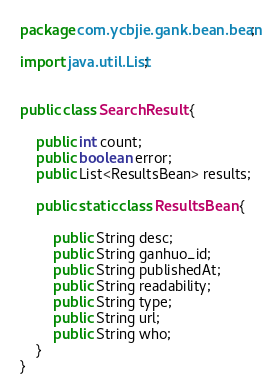<code> <loc_0><loc_0><loc_500><loc_500><_Java_>package com.ycbjie.gank.bean.bean;

import java.util.List;


public class SearchResult {

    public int count;
    public boolean error;
    public List<ResultsBean> results;

    public static class ResultsBean {

        public String desc;
        public String ganhuo_id;
        public String publishedAt;
        public String readability;
        public String type;
        public String url;
        public String who;
    }
}
</code> 